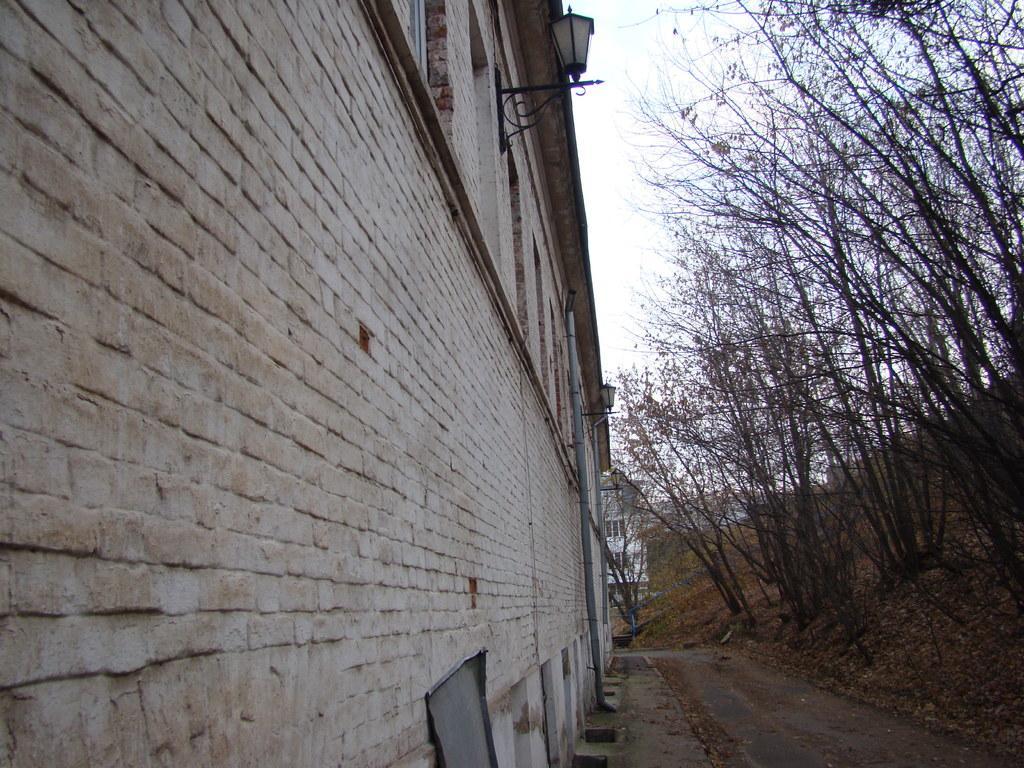Could you give a brief overview of what you see in this image? In this image on the left side there are some buildings and on the right side there are some trees and grass. At the bottom there is a road and at the top of the image there is sky, and also there are some lights and pipes. 